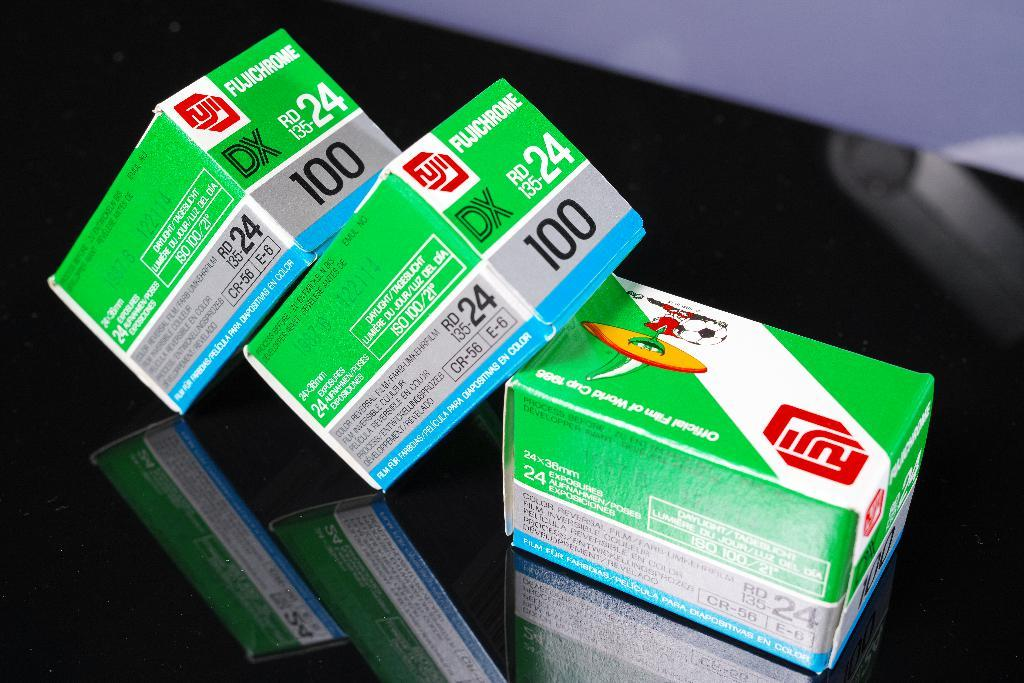<image>
Summarize the visual content of the image. three green and white boxes with fujichrome written on the top two 